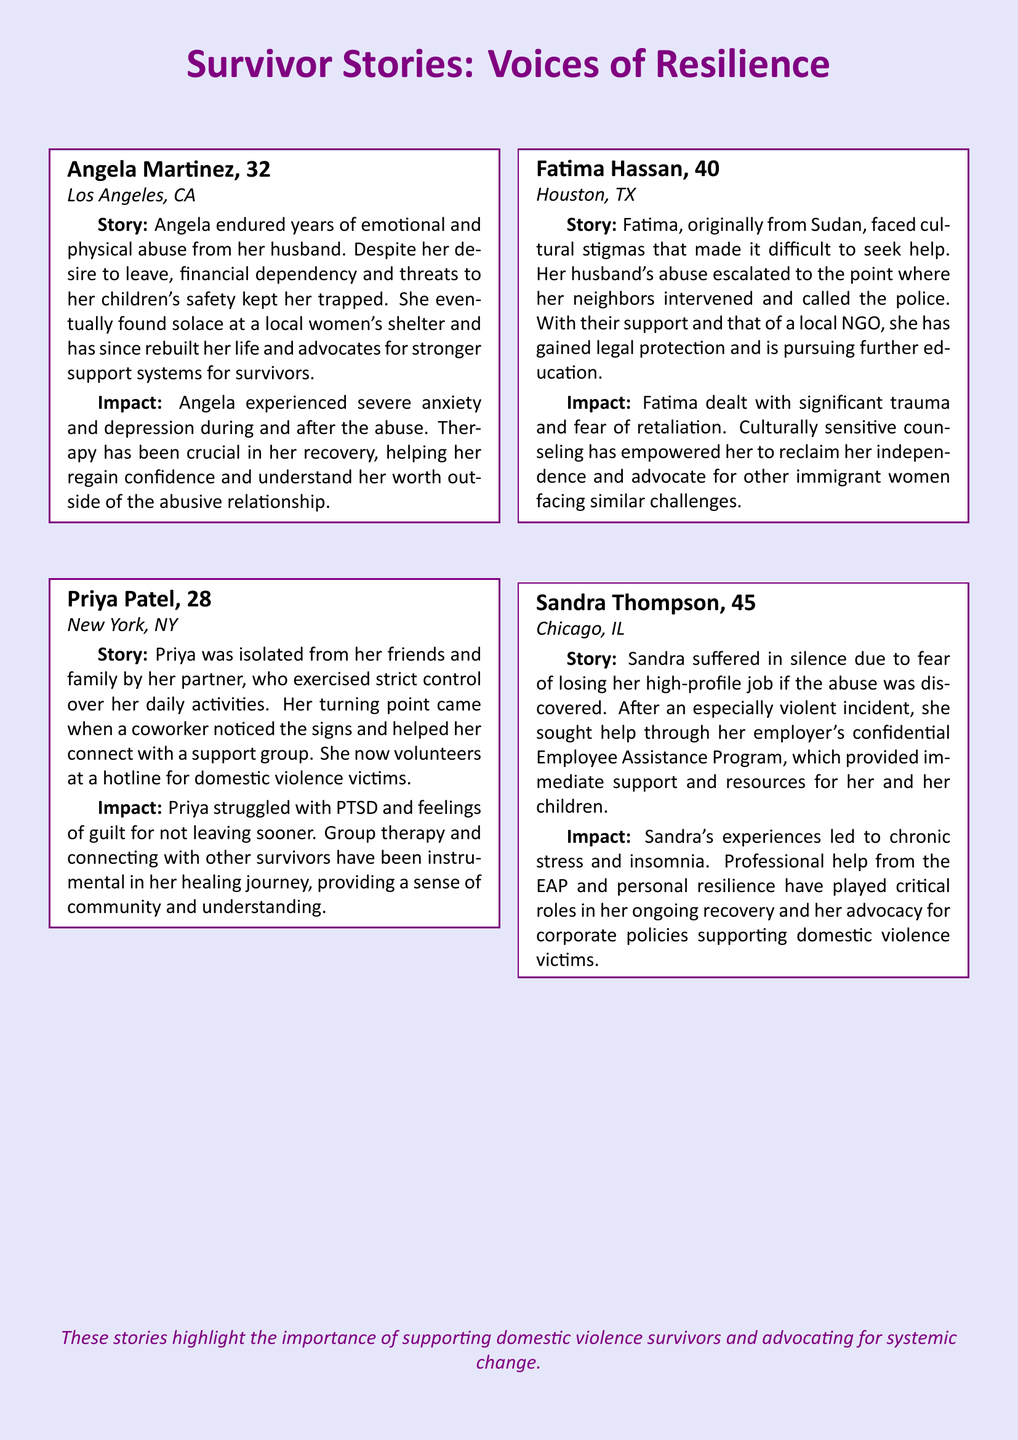What is the age of Angela Martinez? Angela Martinez is listed with her age in the document.
Answer: 32 What city does Priya Patel live in? The document specifies each survivor's location, and Priya Patel's location is mentioned.
Answer: New York, NY How many survivors' stories are included in the document? The document contains narratives from four individuals, as indicated by the loop in the code.
Answer: 4 What was Fatima Hassan's major challenge in seeking help? The narrative for Fatima mentions specific obstacles she faced, providing context to her situation.
Answer: Cultural stigmas What type of therapy has Angela found crucial for her recovery? Angela's impact statement refers to a specific type of support received during her healing process.
Answer: Therapy What role did a coworker play in Priya Patel's experience? The narrative explains the influence of Priya's coworker in her journey toward seeking help.
Answer: Helped connect to a support group What assistance did Sandra Thompson receive from her employer? Sandra mentions the specific type of program that provided her with support in her time of need.
Answer: Employee Assistance Program What is a common emotional impact faced by the survivors? Each survivor's impact statement highlights psychological struggles faced during and after the abuse.
Answer: Anxiety and depression How has Fatima Hassan's situation evolved since receiving help? The narrative describes the positive changes in Fatima's life following interventions from her neighbors and NGOs.
Answer: Gained legal protection and is pursuing education 